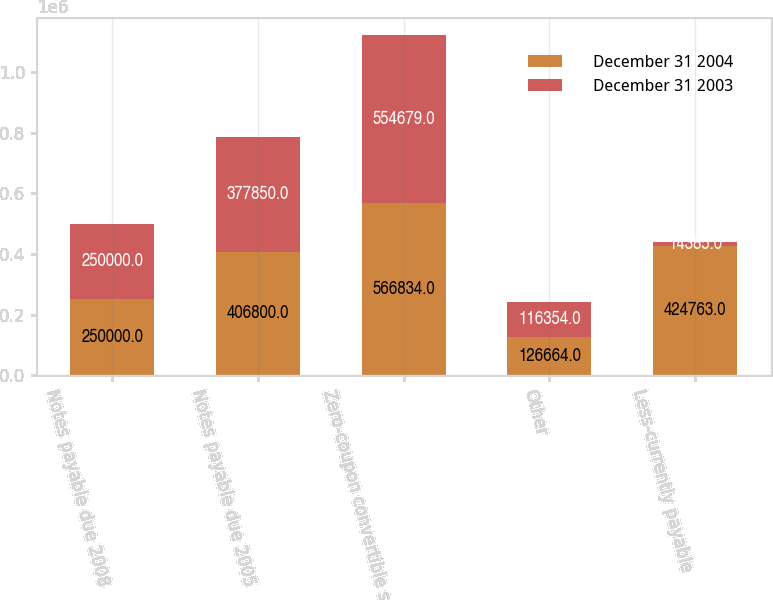<chart> <loc_0><loc_0><loc_500><loc_500><stacked_bar_chart><ecel><fcel>Notes payable due 2008<fcel>Notes payable due 2005<fcel>Zero-coupon convertible senior<fcel>Other<fcel>Less-currently payable<nl><fcel>December 31 2004<fcel>250000<fcel>406800<fcel>566834<fcel>126664<fcel>424763<nl><fcel>December 31 2003<fcel>250000<fcel>377850<fcel>554679<fcel>116354<fcel>14385<nl></chart> 